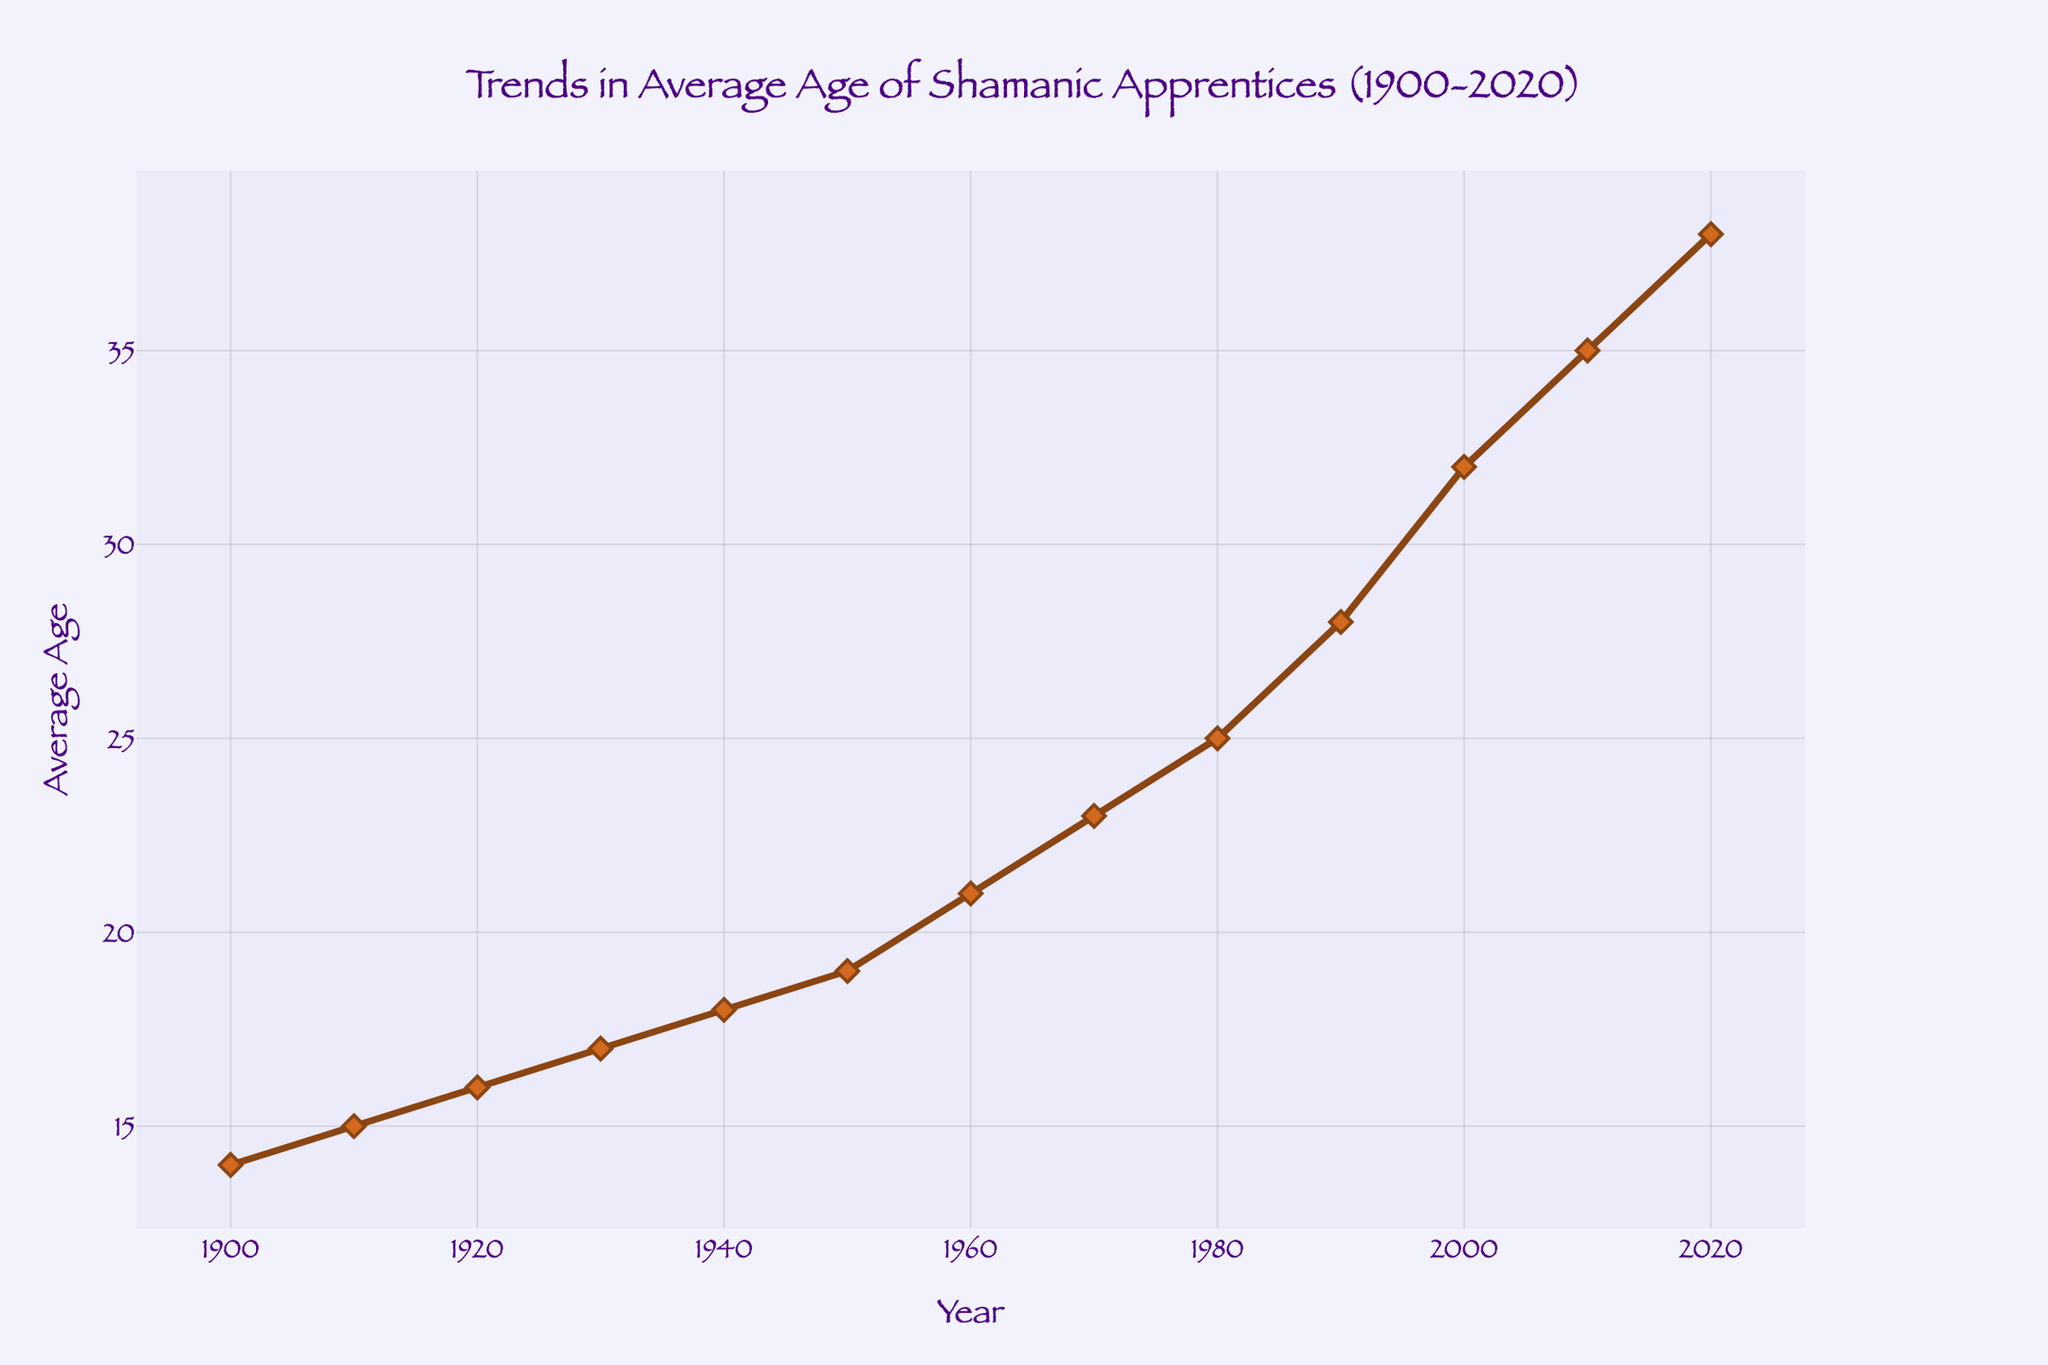What is the overall trend in the average age of shamanic apprentices from 1900 to 2020? The figure shows a steady increase in the average age of apprentices over time. This indicates that people have been starting their training at older ages as the years progress.
Answer: Increasing In which decade did the average age of apprentices see the most significant increase? Comparing the increases between decades, the most significant jump occurs between the 1990s and 2000s, where the average age rose from 28 to 32.
Answer: 1990s to 2000s What was the average age of shamanic apprentices in the year 1960? To determine the average age in 1960, observe the point on the line corresponding to the year 1960. The value is 21.
Answer: 21 How much did the average age of apprentices increase from 1950 to 1980? The average age in 1950 was 19, and by 1980 it was 25. The increase is calculated by subtracting 19 from 25.
Answer: 6 What is the difference in the average age of apprentices between the years 1910 and 2020? The average age in 1910 was 15, and in 2020 it was 38. Subtracting 15 from 38 gives the difference.
Answer: 23 Did the average age of shamanic apprentices ever decrease between 1900 and 2020? Observing the trendline, there are no points where the average age decreases; it consistently increases.
Answer: No Compare the average age of apprentices in 1900 and 2000. Which year had a higher average age and by how much? The average age in 1900 was 14, and in 2000 it was 32. The difference is 32 - 14 = 18.
Answer: 2000, by 18 What can be inferred about the societal changes affecting shamanic apprenticeships based on the trend shown? The increasing ages suggest that either apprentices are starting later in life due to extended education or career commitments, or perhaps the tradition is evolving to include older individuals.
Answer: Later starting ages, societal changes How does the average age trend from 1980 to 2000 compare to the trend from 2000 to 2020? From 1980 to 2000, the average age rose from 25 to 32 (7 years increase), and from 2000 to 2020, it increased from 32 to 38 (6 years increase).
Answer: Slightly faster increase before 2000 What was the average age trend in the first half of the 20th century (1900-1950)? In this period, the average age increased steadily, rising from 14 in 1900 to 19 in 1950.
Answer: Steadily increasing 